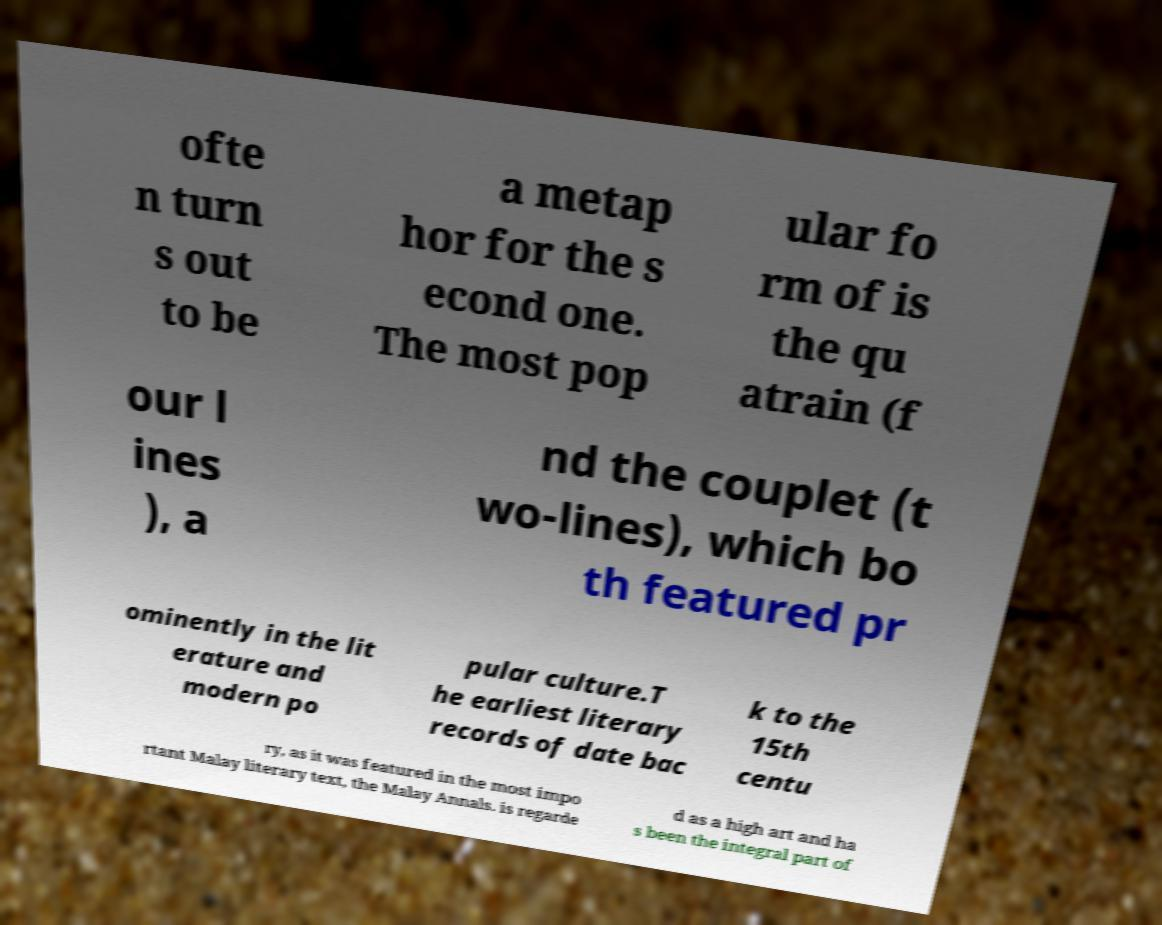For documentation purposes, I need the text within this image transcribed. Could you provide that? ofte n turn s out to be a metap hor for the s econd one. The most pop ular fo rm of is the qu atrain (f our l ines ), a nd the couplet (t wo-lines), which bo th featured pr ominently in the lit erature and modern po pular culture.T he earliest literary records of date bac k to the 15th centu ry, as it was featured in the most impo rtant Malay literary text, the Malay Annals. is regarde d as a high art and ha s been the integral part of 